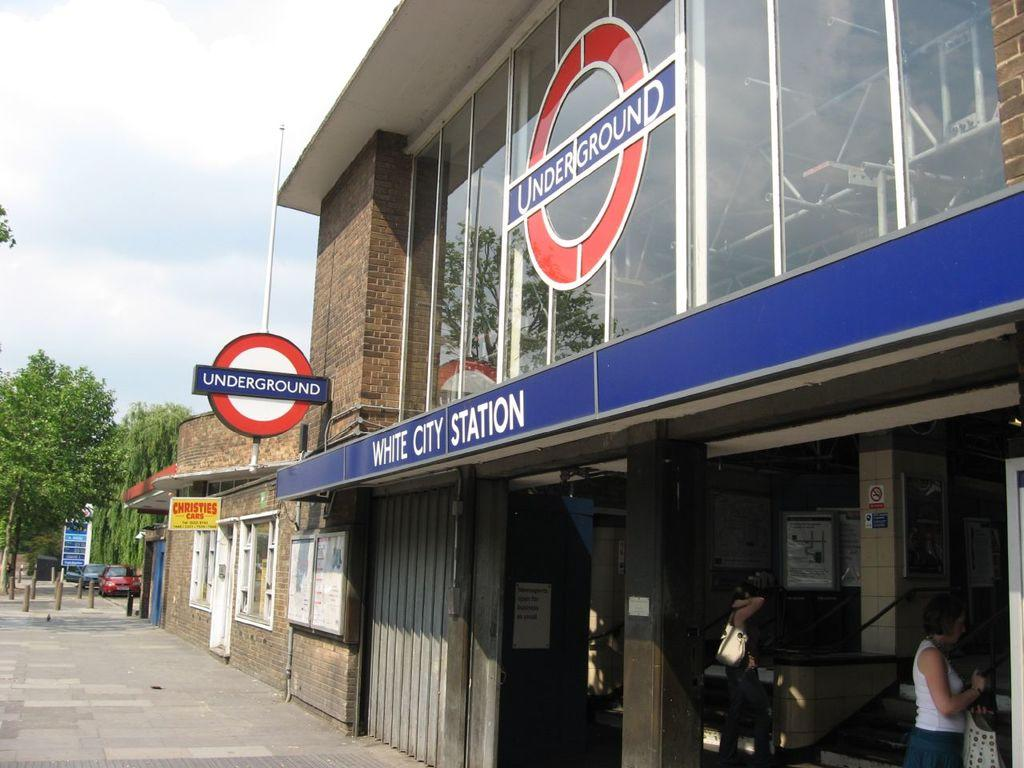What can be seen on the right side of the image in the foreground? There are buildings, boards, and a pole in the foreground on the right side of the image. What is visible in the background of the image? There are trees, bollards, vehicles, a pavement, and the sky in the background of the image. Can you describe the sky in the image? The sky is visible in the background of the image, and there is a cloud visible in the sky. What type of wood is being used to create humor in the image? There is no wood or humor present in the image. What is the current status of the vehicles in the background of the image? The provided facts do not mention the current status of the vehicles, only that they are visible in the background of the image. 